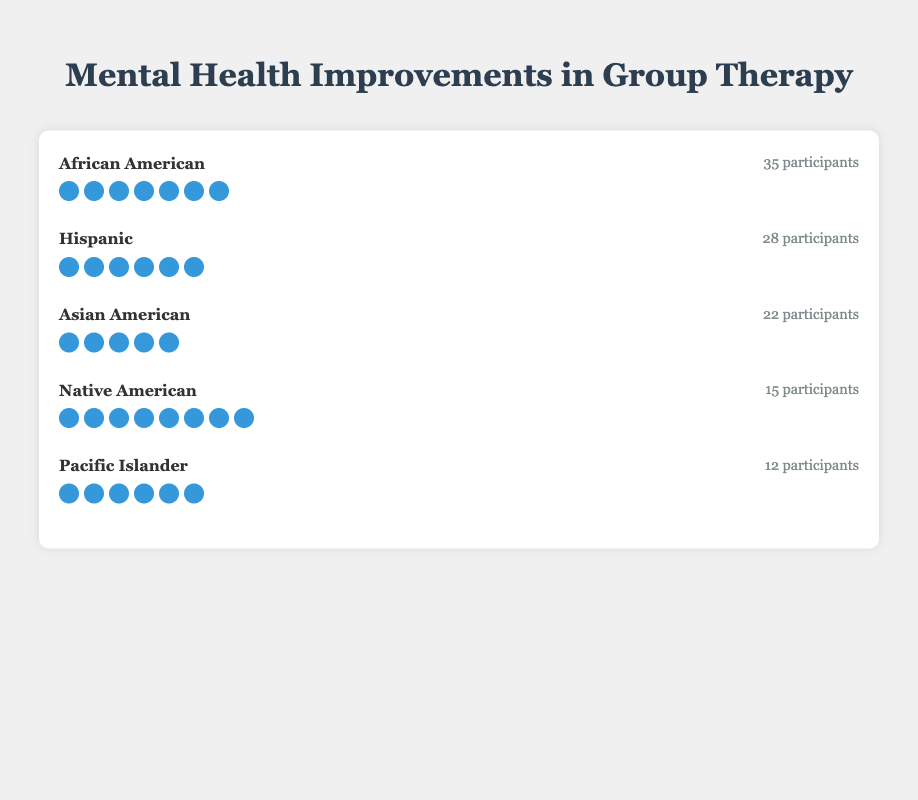What is the improvement level of the African American group? The African American group has seven icons representing the level of improvement.
Answer: 7 How many participants are in the Hispanic group? Next to the improvement icons of the Hispanic group, it is written "28 participants."
Answer: 28 Which ethnic group has the highest mental health improvement level? The highest improvement level is seen in the Native American group, which has 8 icons.
Answer: Native American What's the sum of participants in the Asian American and Pacific Islander groups? The Asian American group has 22 participants, and the Pacific Islander group has 12. Adding them together gives 22 + 12 = 34.
Answer: 34 How many more participants are there in the African American group compared to the Native American group? The African American group has 35 participants and the Native American group has 15. The difference is 35 - 15 = 20.
Answer: 20 Which two ethnic groups have the same level of improvement? The Hispanic and Pacific Islander groups both have six icons representing their level of improvement.
Answer: Hispanic and Pacific Islander What is the average improvement level among all ethnic groups? Sum of improvement levels: 7 + 6 + 5 + 8 + 6 = 32. The number of groups is 5. The average is 32 / 5 = 6.4.
Answer: 6.4 How many ethnic groups have an improvement level greater than 5? There are three groups with an improvement level greater than 5: African American (7), Native American (8), and Hispanic (6).
Answer: 3 Which ethnic group has the lowest number of participants? The Pacific Islander group has the lowest number of participants with 12.
Answer: Pacific Islander 